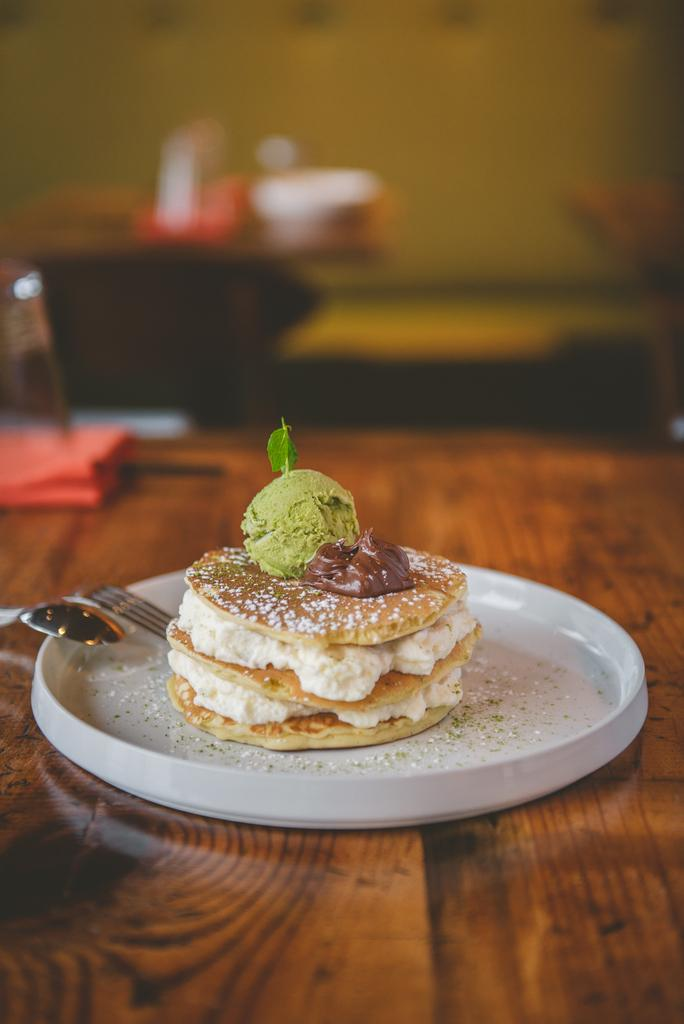What type of objects can be seen in the image? There are food items in the image. Where are the food items placed? The food items are placed on a white-colored object. What is the surface beneath the white-colored object? The white-colored object is on a wooden surface. What utensils are visible in the image? There are spoons visible in the image. Can you describe the background of the image? The background of the image is blurred. What type of key is used to unlock the food items in the image? There is no key present in the image, and the food items are not locked. 